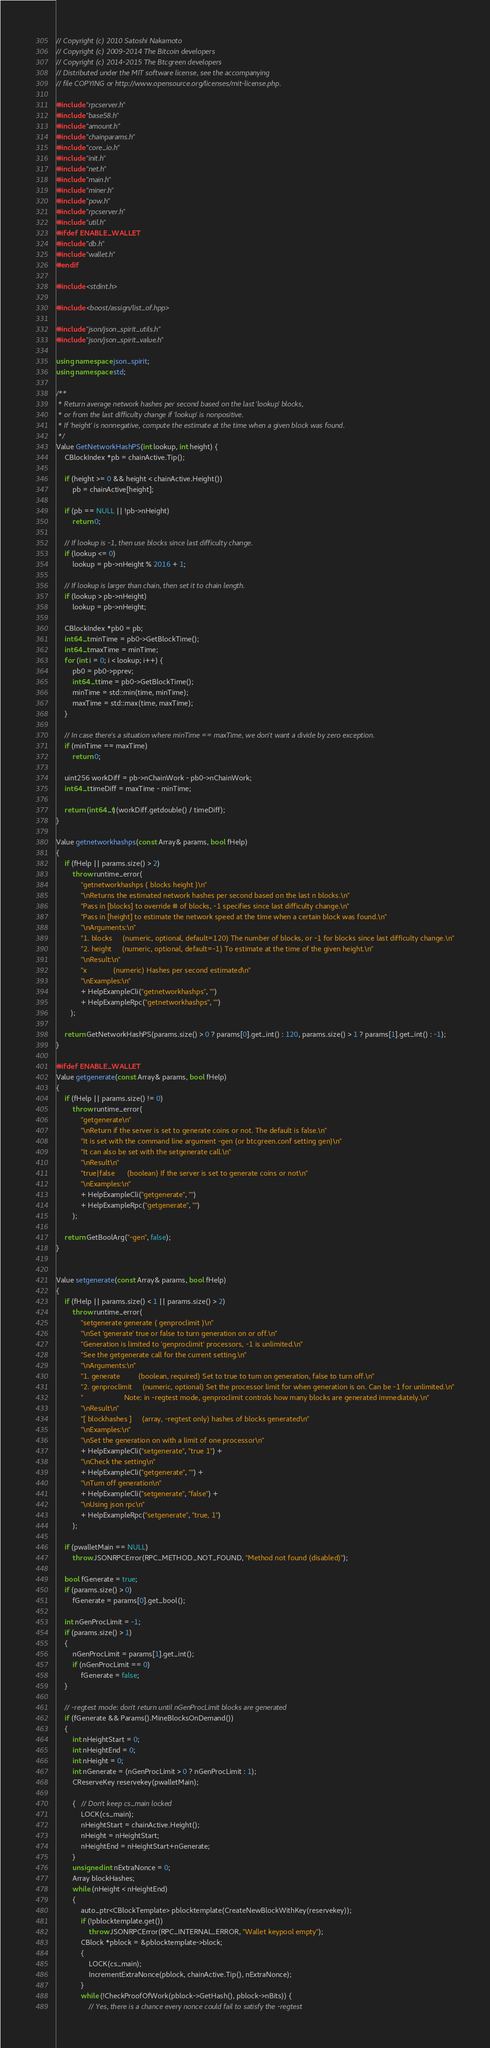Convert code to text. <code><loc_0><loc_0><loc_500><loc_500><_C++_>// Copyright (c) 2010 Satoshi Nakamoto
// Copyright (c) 2009-2014 The Bitcoin developers
// Copyright (c) 2014-2015 The Btcgreen developers
// Distributed under the MIT software license, see the accompanying
// file COPYING or http://www.opensource.org/licenses/mit-license.php.

#include "rpcserver.h"
#include "base58.h"
#include "amount.h"
#include "chainparams.h"
#include "core_io.h"
#include "init.h"
#include "net.h"
#include "main.h"
#include "miner.h"
#include "pow.h"
#include "rpcserver.h"
#include "util.h"
#ifdef ENABLE_WALLET
#include "db.h"
#include "wallet.h"
#endif

#include <stdint.h>

#include <boost/assign/list_of.hpp>

#include "json/json_spirit_utils.h"
#include "json/json_spirit_value.h"

using namespace json_spirit;
using namespace std;

/**
 * Return average network hashes per second based on the last 'lookup' blocks,
 * or from the last difficulty change if 'lookup' is nonpositive.
 * If 'height' is nonnegative, compute the estimate at the time when a given block was found.
 */
Value GetNetworkHashPS(int lookup, int height) {
    CBlockIndex *pb = chainActive.Tip();

    if (height >= 0 && height < chainActive.Height())
        pb = chainActive[height];

    if (pb == NULL || !pb->nHeight)
        return 0;

    // If lookup is -1, then use blocks since last difficulty change.
    if (lookup <= 0)
        lookup = pb->nHeight % 2016 + 1;

    // If lookup is larger than chain, then set it to chain length.
    if (lookup > pb->nHeight)
        lookup = pb->nHeight;

    CBlockIndex *pb0 = pb;
    int64_t minTime = pb0->GetBlockTime();
    int64_t maxTime = minTime;
    for (int i = 0; i < lookup; i++) {
        pb0 = pb0->pprev;
        int64_t time = pb0->GetBlockTime();
        minTime = std::min(time, minTime);
        maxTime = std::max(time, maxTime);
    }

    // In case there's a situation where minTime == maxTime, we don't want a divide by zero exception.
    if (minTime == maxTime)
        return 0;

    uint256 workDiff = pb->nChainWork - pb0->nChainWork;
    int64_t timeDiff = maxTime - minTime;

    return (int64_t)(workDiff.getdouble() / timeDiff);
}

Value getnetworkhashps(const Array& params, bool fHelp)
{
    if (fHelp || params.size() > 2)
        throw runtime_error(
            "getnetworkhashps ( blocks height )\n"
            "\nReturns the estimated network hashes per second based on the last n blocks.\n"
            "Pass in [blocks] to override # of blocks, -1 specifies since last difficulty change.\n"
            "Pass in [height] to estimate the network speed at the time when a certain block was found.\n"
            "\nArguments:\n"
            "1. blocks     (numeric, optional, default=120) The number of blocks, or -1 for blocks since last difficulty change.\n"
            "2. height     (numeric, optional, default=-1) To estimate at the time of the given height.\n"
            "\nResult:\n"
            "x             (numeric) Hashes per second estimated\n"
            "\nExamples:\n"
            + HelpExampleCli("getnetworkhashps", "")
            + HelpExampleRpc("getnetworkhashps", "")
       );

    return GetNetworkHashPS(params.size() > 0 ? params[0].get_int() : 120, params.size() > 1 ? params[1].get_int() : -1);
}

#ifdef ENABLE_WALLET
Value getgenerate(const Array& params, bool fHelp)
{
    if (fHelp || params.size() != 0)
        throw runtime_error(
            "getgenerate\n"
            "\nReturn if the server is set to generate coins or not. The default is false.\n"
            "It is set with the command line argument -gen (or btcgreen.conf setting gen)\n"
            "It can also be set with the setgenerate call.\n"
            "\nResult\n"
            "true|false      (boolean) If the server is set to generate coins or not\n"
            "\nExamples:\n"
            + HelpExampleCli("getgenerate", "")
            + HelpExampleRpc("getgenerate", "")
        );

    return GetBoolArg("-gen", false);
}


Value setgenerate(const Array& params, bool fHelp)
{
    if (fHelp || params.size() < 1 || params.size() > 2)
        throw runtime_error(
            "setgenerate generate ( genproclimit )\n"
            "\nSet 'generate' true or false to turn generation on or off.\n"
            "Generation is limited to 'genproclimit' processors, -1 is unlimited.\n"
            "See the getgenerate call for the current setting.\n"
            "\nArguments:\n"
            "1. generate         (boolean, required) Set to true to turn on generation, false to turn off.\n"
            "2. genproclimit     (numeric, optional) Set the processor limit for when generation is on. Can be -1 for unlimited.\n"
            "                    Note: in -regtest mode, genproclimit controls how many blocks are generated immediately.\n"
            "\nResult\n"
            "[ blockhashes ]     (array, -regtest only) hashes of blocks generated\n"
            "\nExamples:\n"
            "\nSet the generation on with a limit of one processor\n"
            + HelpExampleCli("setgenerate", "true 1") +
            "\nCheck the setting\n"
            + HelpExampleCli("getgenerate", "") +
            "\nTurn off generation\n"
            + HelpExampleCli("setgenerate", "false") +
            "\nUsing json rpc\n"
            + HelpExampleRpc("setgenerate", "true, 1")
        );

    if (pwalletMain == NULL)
        throw JSONRPCError(RPC_METHOD_NOT_FOUND, "Method not found (disabled)");

    bool fGenerate = true;
    if (params.size() > 0)
        fGenerate = params[0].get_bool();

    int nGenProcLimit = -1;
    if (params.size() > 1)
    {
        nGenProcLimit = params[1].get_int();
        if (nGenProcLimit == 0)
            fGenerate = false;
    }

    // -regtest mode: don't return until nGenProcLimit blocks are generated
    if (fGenerate && Params().MineBlocksOnDemand())
    {
        int nHeightStart = 0;
        int nHeightEnd = 0;
        int nHeight = 0;
        int nGenerate = (nGenProcLimit > 0 ? nGenProcLimit : 1);
        CReserveKey reservekey(pwalletMain);

        {   // Don't keep cs_main locked
            LOCK(cs_main);
            nHeightStart = chainActive.Height();
            nHeight = nHeightStart;
            nHeightEnd = nHeightStart+nGenerate;
        }
        unsigned int nExtraNonce = 0;
        Array blockHashes;
        while (nHeight < nHeightEnd)
        {
            auto_ptr<CBlockTemplate> pblocktemplate(CreateNewBlockWithKey(reservekey));
            if (!pblocktemplate.get())
                throw JSONRPCError(RPC_INTERNAL_ERROR, "Wallet keypool empty");
            CBlock *pblock = &pblocktemplate->block;
            {
                LOCK(cs_main);
                IncrementExtraNonce(pblock, chainActive.Tip(), nExtraNonce);
            }
            while (!CheckProofOfWork(pblock->GetHash(), pblock->nBits)) {
                // Yes, there is a chance every nonce could fail to satisfy the -regtest</code> 